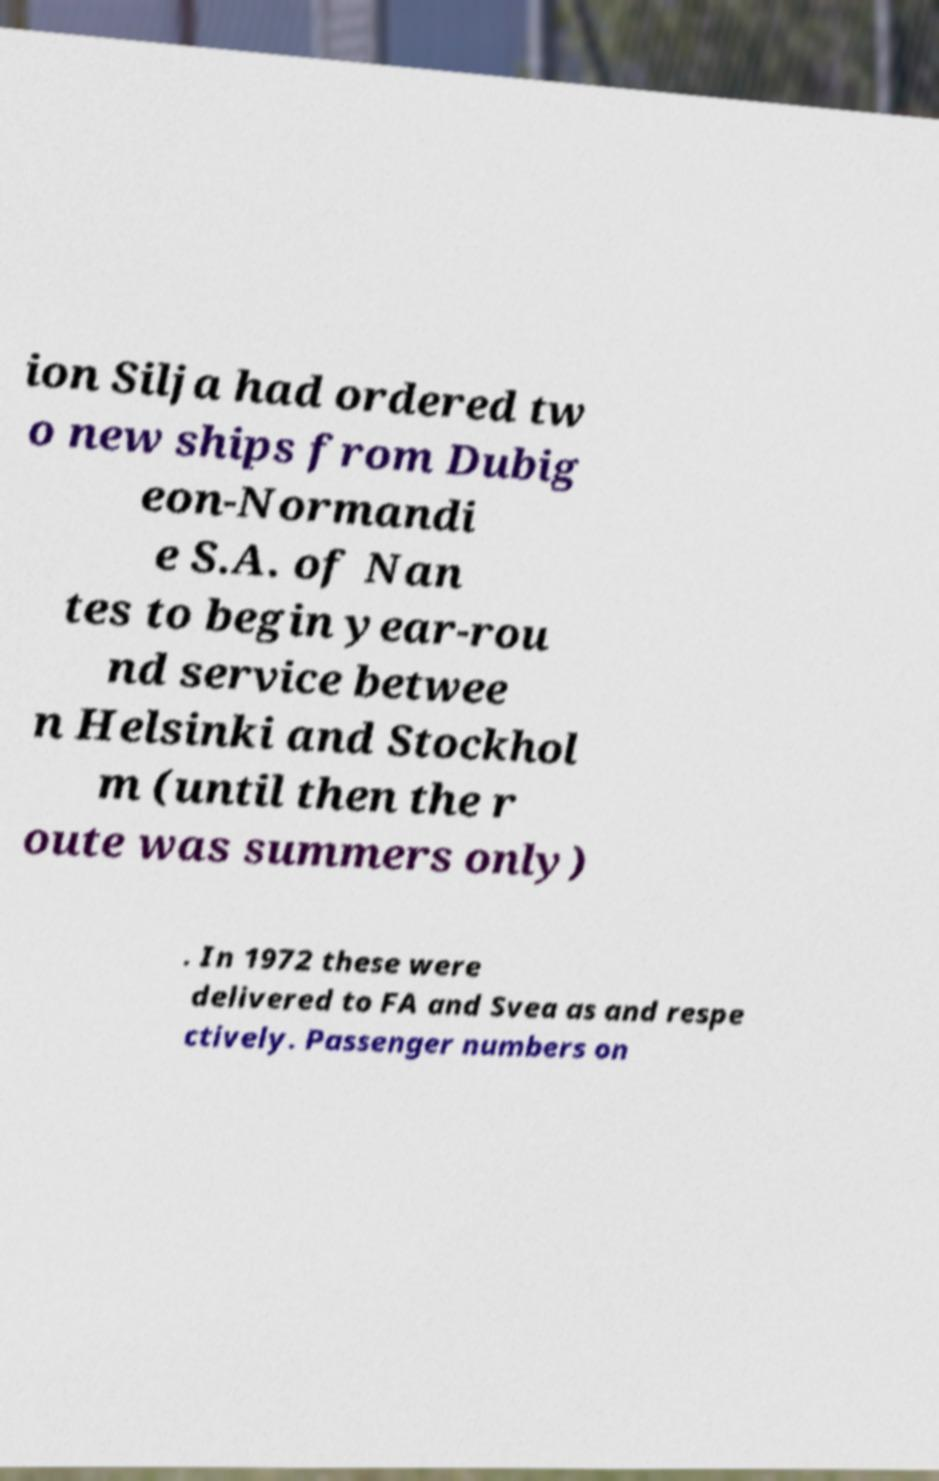Please identify and transcribe the text found in this image. ion Silja had ordered tw o new ships from Dubig eon-Normandi e S.A. of Nan tes to begin year-rou nd service betwee n Helsinki and Stockhol m (until then the r oute was summers only) . In 1972 these were delivered to FA and Svea as and respe ctively. Passenger numbers on 